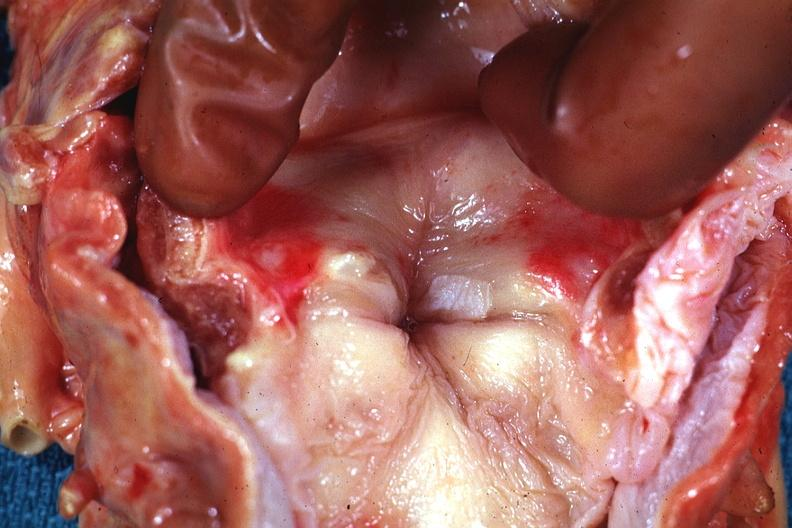what is present?
Answer the question using a single word or phrase. Leukoplakia vocal cord 